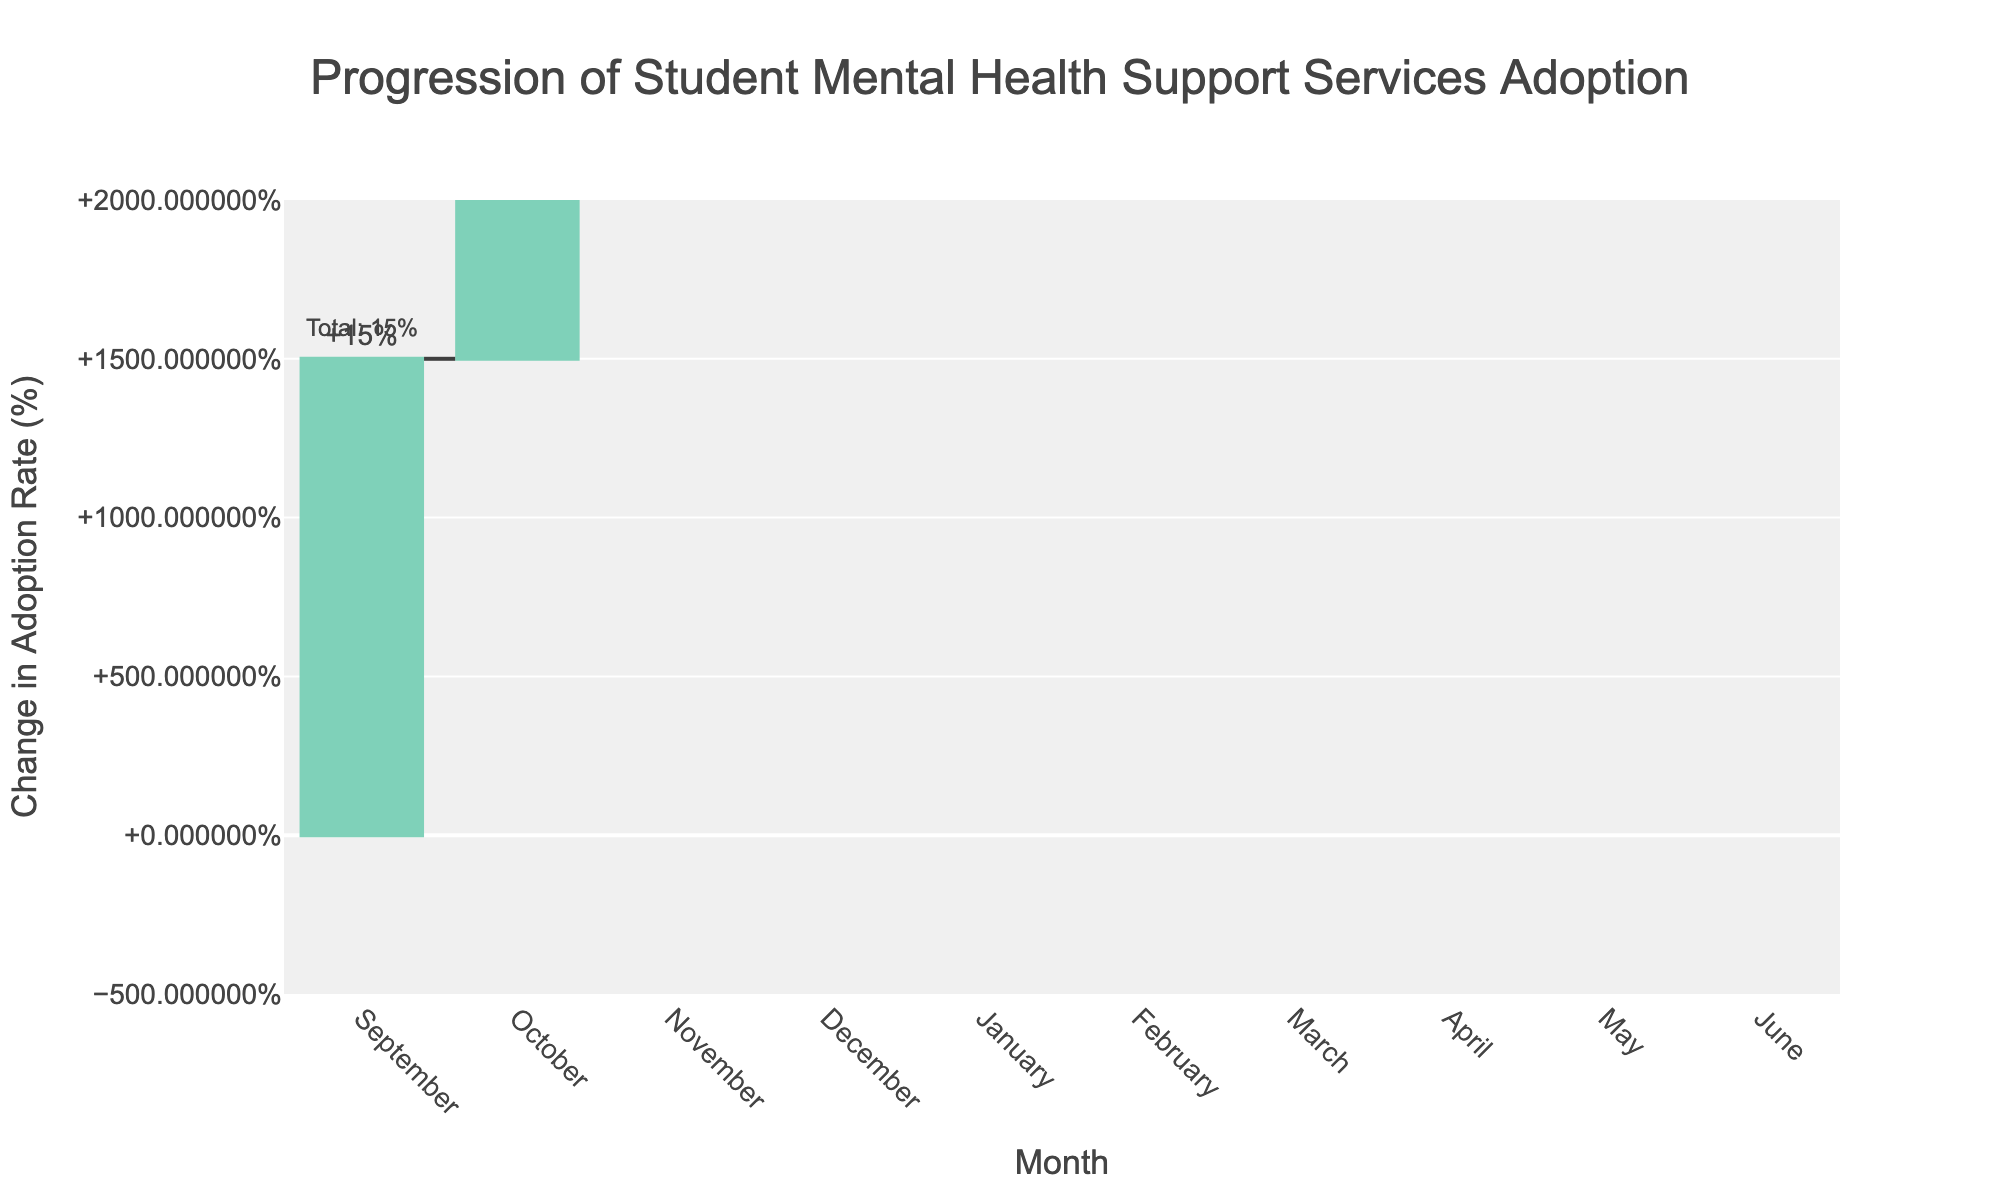What's the title of the figure? The title is written at the top-center of the figure. It reads: "Progression of Student Mental Health Support Services Adoption".
Answer: Progression of Student Mental Health Support Services Adoption What is the change in adoption rate for December? Each month’s change is labeled outside the bars. For December, it shows a "−2%".
Answer: −2% What is the running total adoption rate by the end of January? The dataset includes running totals for each month, which are also annotated on the chart. By the end of January, it is shown as "Total: 38%".
Answer: 38% Which month had the highest increase in adoption rate? By comparing the changes indicated outside each month's bar, January stands out with a "+12%".
Answer: January How many months experienced a decrease in the adoption rate? Look for negative percentage changes outside of the month bars. There are two: December (−2%) and May (−3%).
Answer: 2 What is the cumulative adoption rate by the end of the academic year (June)? The final annotation indicates the running total and is shown as "Total: 60%".
Answer: 60% Which month had the smallest positive increase in adoption rate? By examining the positive changes outside the month bars, the smallest is "+4%" in March.
Answer: March How does the adoption rate change from February to March? The adoption rate in February is at 45%, and by the end of March, it is 49%. The net change is "+4%".
Answer: +4% What were the adoption rate changes in the spring semester (March to June)? By observing the individual changes: March (+4%), April (+6%), May (−3%), and June (+8%). Sum these: 4% + 6% − 3% + 8% = +15%.
Answer: +15% What is the difference between the highest and lowest monthly changes? The highest monthly change is "+12%" in January, and the lowest is "−3%" in May. The difference is 12% − (−3%) = 12% + 3% = 15%.
Answer: 15% 